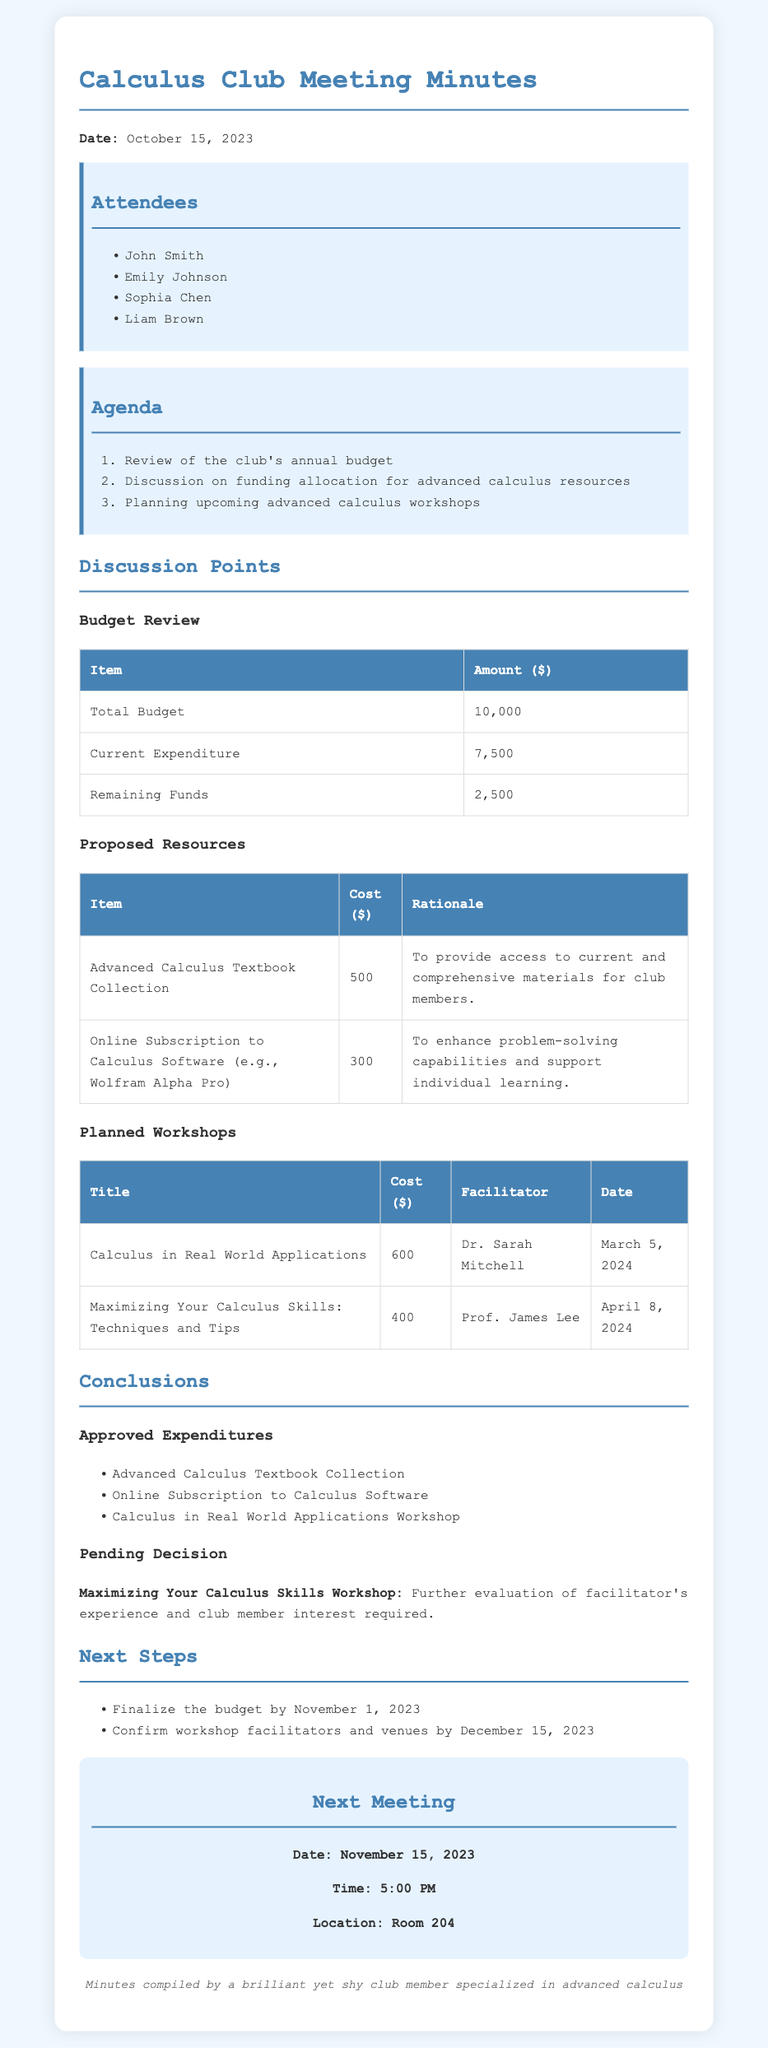What is the date of the meeting? The date of the meeting is provided at the start of the minutes.
Answer: October 15, 2023 Who is the facilitator for the "Calculus in Real World Applications" workshop? The facilitator's name for this workshop is listed in the planned workshops section.
Answer: Dr. Sarah Mitchell What is the cost of the advanced calculus textbook collection? The proposed resources section indicates the cost of the textbook collection.
Answer: 500 What is the total budget for the club? The total budget is stated in the budget review table.
Answer: 10,000 Which workshop is pending a decision? The pending decision is mentioned in the conclusions section of the minutes.
Answer: Maximizing Your Calculus Skills Workshop What is the remaining fund after current expenditure? The remaining funds are calculated and displayed in the budget review table.
Answer: 2,500 By when must the budget be finalized? The next steps section provides the deadline for finalizing the budget.
Answer: November 1, 2023 What is included in the approved expenditures? The list of approved expenditures is summarized in the conclusions section.
Answer: Advanced Calculus Textbook Collection What is the date and time of the next meeting? The next meeting details are provided in the next meeting section.
Answer: November 15, 2023, 5:00 PM 